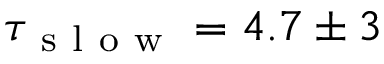<formula> <loc_0><loc_0><loc_500><loc_500>\tau _ { s l o w } = 4 . 7 \pm 3</formula> 